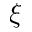Convert formula to latex. <formula><loc_0><loc_0><loc_500><loc_500>\xi</formula> 